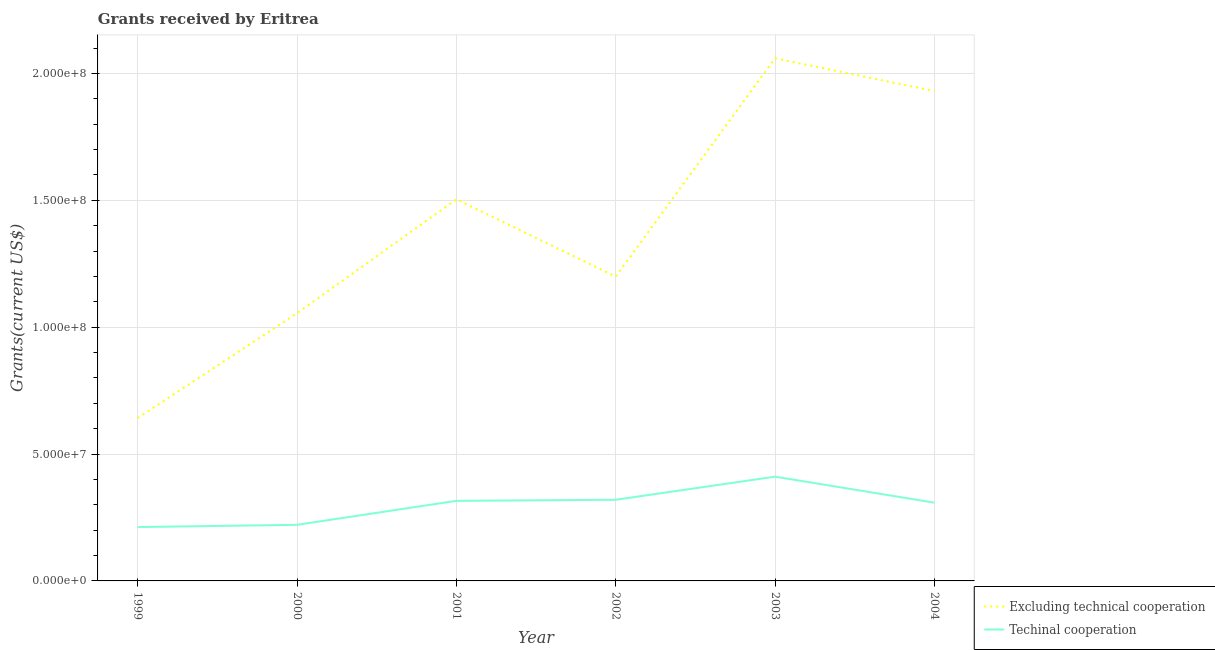Does the line corresponding to amount of grants received(including technical cooperation) intersect with the line corresponding to amount of grants received(excluding technical cooperation)?
Your answer should be compact. No. Is the number of lines equal to the number of legend labels?
Your answer should be compact. Yes. What is the amount of grants received(excluding technical cooperation) in 1999?
Give a very brief answer. 6.42e+07. Across all years, what is the maximum amount of grants received(excluding technical cooperation)?
Offer a very short reply. 2.06e+08. Across all years, what is the minimum amount of grants received(excluding technical cooperation)?
Your answer should be very brief. 6.42e+07. What is the total amount of grants received(including technical cooperation) in the graph?
Give a very brief answer. 1.79e+08. What is the difference between the amount of grants received(excluding technical cooperation) in 1999 and that in 2000?
Offer a terse response. -4.13e+07. What is the difference between the amount of grants received(including technical cooperation) in 2004 and the amount of grants received(excluding technical cooperation) in 2002?
Your answer should be compact. -8.91e+07. What is the average amount of grants received(excluding technical cooperation) per year?
Offer a very short reply. 1.40e+08. In the year 2003, what is the difference between the amount of grants received(including technical cooperation) and amount of grants received(excluding technical cooperation)?
Give a very brief answer. -1.65e+08. What is the ratio of the amount of grants received(including technical cooperation) in 2001 to that in 2002?
Provide a succinct answer. 0.99. Is the amount of grants received(excluding technical cooperation) in 2000 less than that in 2003?
Provide a short and direct response. Yes. What is the difference between the highest and the second highest amount of grants received(including technical cooperation)?
Keep it short and to the point. 9.11e+06. What is the difference between the highest and the lowest amount of grants received(excluding technical cooperation)?
Your response must be concise. 1.42e+08. In how many years, is the amount of grants received(excluding technical cooperation) greater than the average amount of grants received(excluding technical cooperation) taken over all years?
Offer a very short reply. 3. Does the amount of grants received(excluding technical cooperation) monotonically increase over the years?
Keep it short and to the point. No. Is the amount of grants received(including technical cooperation) strictly greater than the amount of grants received(excluding technical cooperation) over the years?
Offer a very short reply. No. Is the amount of grants received(excluding technical cooperation) strictly less than the amount of grants received(including technical cooperation) over the years?
Offer a terse response. No. How many lines are there?
Provide a short and direct response. 2. Are the values on the major ticks of Y-axis written in scientific E-notation?
Offer a very short reply. Yes. Does the graph contain grids?
Your response must be concise. Yes. How are the legend labels stacked?
Offer a very short reply. Vertical. What is the title of the graph?
Make the answer very short. Grants received by Eritrea. Does "Registered firms" appear as one of the legend labels in the graph?
Provide a succinct answer. No. What is the label or title of the X-axis?
Keep it short and to the point. Year. What is the label or title of the Y-axis?
Provide a succinct answer. Grants(current US$). What is the Grants(current US$) in Excluding technical cooperation in 1999?
Your answer should be very brief. 6.42e+07. What is the Grants(current US$) of Techinal cooperation in 1999?
Your response must be concise. 2.12e+07. What is the Grants(current US$) in Excluding technical cooperation in 2000?
Provide a succinct answer. 1.06e+08. What is the Grants(current US$) in Techinal cooperation in 2000?
Your answer should be very brief. 2.21e+07. What is the Grants(current US$) of Excluding technical cooperation in 2001?
Make the answer very short. 1.50e+08. What is the Grants(current US$) of Techinal cooperation in 2001?
Offer a terse response. 3.16e+07. What is the Grants(current US$) of Excluding technical cooperation in 2002?
Provide a succinct answer. 1.20e+08. What is the Grants(current US$) of Techinal cooperation in 2002?
Ensure brevity in your answer.  3.20e+07. What is the Grants(current US$) of Excluding technical cooperation in 2003?
Give a very brief answer. 2.06e+08. What is the Grants(current US$) of Techinal cooperation in 2003?
Offer a very short reply. 4.11e+07. What is the Grants(current US$) in Excluding technical cooperation in 2004?
Provide a succinct answer. 1.93e+08. What is the Grants(current US$) in Techinal cooperation in 2004?
Offer a very short reply. 3.08e+07. Across all years, what is the maximum Grants(current US$) in Excluding technical cooperation?
Provide a succinct answer. 2.06e+08. Across all years, what is the maximum Grants(current US$) in Techinal cooperation?
Make the answer very short. 4.11e+07. Across all years, what is the minimum Grants(current US$) of Excluding technical cooperation?
Give a very brief answer. 6.42e+07. Across all years, what is the minimum Grants(current US$) in Techinal cooperation?
Offer a terse response. 2.12e+07. What is the total Grants(current US$) in Excluding technical cooperation in the graph?
Provide a succinct answer. 8.39e+08. What is the total Grants(current US$) of Techinal cooperation in the graph?
Make the answer very short. 1.79e+08. What is the difference between the Grants(current US$) in Excluding technical cooperation in 1999 and that in 2000?
Your answer should be very brief. -4.13e+07. What is the difference between the Grants(current US$) in Techinal cooperation in 1999 and that in 2000?
Provide a short and direct response. -8.90e+05. What is the difference between the Grants(current US$) of Excluding technical cooperation in 1999 and that in 2001?
Offer a very short reply. -8.62e+07. What is the difference between the Grants(current US$) in Techinal cooperation in 1999 and that in 2001?
Provide a succinct answer. -1.03e+07. What is the difference between the Grants(current US$) in Excluding technical cooperation in 1999 and that in 2002?
Your answer should be compact. -5.58e+07. What is the difference between the Grants(current US$) of Techinal cooperation in 1999 and that in 2002?
Make the answer very short. -1.08e+07. What is the difference between the Grants(current US$) of Excluding technical cooperation in 1999 and that in 2003?
Provide a short and direct response. -1.42e+08. What is the difference between the Grants(current US$) in Techinal cooperation in 1999 and that in 2003?
Provide a short and direct response. -1.99e+07. What is the difference between the Grants(current US$) in Excluding technical cooperation in 1999 and that in 2004?
Ensure brevity in your answer.  -1.29e+08. What is the difference between the Grants(current US$) of Techinal cooperation in 1999 and that in 2004?
Your answer should be compact. -9.62e+06. What is the difference between the Grants(current US$) in Excluding technical cooperation in 2000 and that in 2001?
Keep it short and to the point. -4.49e+07. What is the difference between the Grants(current US$) in Techinal cooperation in 2000 and that in 2001?
Your response must be concise. -9.45e+06. What is the difference between the Grants(current US$) in Excluding technical cooperation in 2000 and that in 2002?
Your response must be concise. -1.44e+07. What is the difference between the Grants(current US$) in Techinal cooperation in 2000 and that in 2002?
Ensure brevity in your answer.  -9.87e+06. What is the difference between the Grants(current US$) in Excluding technical cooperation in 2000 and that in 2003?
Keep it short and to the point. -1.00e+08. What is the difference between the Grants(current US$) in Techinal cooperation in 2000 and that in 2003?
Provide a short and direct response. -1.90e+07. What is the difference between the Grants(current US$) in Excluding technical cooperation in 2000 and that in 2004?
Give a very brief answer. -8.75e+07. What is the difference between the Grants(current US$) in Techinal cooperation in 2000 and that in 2004?
Ensure brevity in your answer.  -8.73e+06. What is the difference between the Grants(current US$) of Excluding technical cooperation in 2001 and that in 2002?
Give a very brief answer. 3.05e+07. What is the difference between the Grants(current US$) of Techinal cooperation in 2001 and that in 2002?
Keep it short and to the point. -4.20e+05. What is the difference between the Grants(current US$) of Excluding technical cooperation in 2001 and that in 2003?
Your response must be concise. -5.56e+07. What is the difference between the Grants(current US$) in Techinal cooperation in 2001 and that in 2003?
Give a very brief answer. -9.53e+06. What is the difference between the Grants(current US$) in Excluding technical cooperation in 2001 and that in 2004?
Keep it short and to the point. -4.26e+07. What is the difference between the Grants(current US$) of Techinal cooperation in 2001 and that in 2004?
Offer a terse response. 7.20e+05. What is the difference between the Grants(current US$) of Excluding technical cooperation in 2002 and that in 2003?
Provide a short and direct response. -8.60e+07. What is the difference between the Grants(current US$) in Techinal cooperation in 2002 and that in 2003?
Make the answer very short. -9.11e+06. What is the difference between the Grants(current US$) of Excluding technical cooperation in 2002 and that in 2004?
Give a very brief answer. -7.31e+07. What is the difference between the Grants(current US$) of Techinal cooperation in 2002 and that in 2004?
Your response must be concise. 1.14e+06. What is the difference between the Grants(current US$) of Excluding technical cooperation in 2003 and that in 2004?
Make the answer very short. 1.29e+07. What is the difference between the Grants(current US$) of Techinal cooperation in 2003 and that in 2004?
Provide a short and direct response. 1.02e+07. What is the difference between the Grants(current US$) of Excluding technical cooperation in 1999 and the Grants(current US$) of Techinal cooperation in 2000?
Your answer should be very brief. 4.21e+07. What is the difference between the Grants(current US$) in Excluding technical cooperation in 1999 and the Grants(current US$) in Techinal cooperation in 2001?
Ensure brevity in your answer.  3.26e+07. What is the difference between the Grants(current US$) in Excluding technical cooperation in 1999 and the Grants(current US$) in Techinal cooperation in 2002?
Your answer should be very brief. 3.22e+07. What is the difference between the Grants(current US$) of Excluding technical cooperation in 1999 and the Grants(current US$) of Techinal cooperation in 2003?
Give a very brief answer. 2.31e+07. What is the difference between the Grants(current US$) in Excluding technical cooperation in 1999 and the Grants(current US$) in Techinal cooperation in 2004?
Ensure brevity in your answer.  3.33e+07. What is the difference between the Grants(current US$) of Excluding technical cooperation in 2000 and the Grants(current US$) of Techinal cooperation in 2001?
Give a very brief answer. 7.40e+07. What is the difference between the Grants(current US$) in Excluding technical cooperation in 2000 and the Grants(current US$) in Techinal cooperation in 2002?
Your answer should be very brief. 7.35e+07. What is the difference between the Grants(current US$) of Excluding technical cooperation in 2000 and the Grants(current US$) of Techinal cooperation in 2003?
Your response must be concise. 6.44e+07. What is the difference between the Grants(current US$) of Excluding technical cooperation in 2000 and the Grants(current US$) of Techinal cooperation in 2004?
Offer a terse response. 7.47e+07. What is the difference between the Grants(current US$) in Excluding technical cooperation in 2001 and the Grants(current US$) in Techinal cooperation in 2002?
Offer a terse response. 1.18e+08. What is the difference between the Grants(current US$) of Excluding technical cooperation in 2001 and the Grants(current US$) of Techinal cooperation in 2003?
Keep it short and to the point. 1.09e+08. What is the difference between the Grants(current US$) of Excluding technical cooperation in 2001 and the Grants(current US$) of Techinal cooperation in 2004?
Offer a terse response. 1.20e+08. What is the difference between the Grants(current US$) of Excluding technical cooperation in 2002 and the Grants(current US$) of Techinal cooperation in 2003?
Keep it short and to the point. 7.88e+07. What is the difference between the Grants(current US$) of Excluding technical cooperation in 2002 and the Grants(current US$) of Techinal cooperation in 2004?
Your answer should be very brief. 8.91e+07. What is the difference between the Grants(current US$) of Excluding technical cooperation in 2003 and the Grants(current US$) of Techinal cooperation in 2004?
Provide a short and direct response. 1.75e+08. What is the average Grants(current US$) in Excluding technical cooperation per year?
Provide a succinct answer. 1.40e+08. What is the average Grants(current US$) of Techinal cooperation per year?
Ensure brevity in your answer.  2.98e+07. In the year 1999, what is the difference between the Grants(current US$) of Excluding technical cooperation and Grants(current US$) of Techinal cooperation?
Ensure brevity in your answer.  4.30e+07. In the year 2000, what is the difference between the Grants(current US$) in Excluding technical cooperation and Grants(current US$) in Techinal cooperation?
Provide a short and direct response. 8.34e+07. In the year 2001, what is the difference between the Grants(current US$) in Excluding technical cooperation and Grants(current US$) in Techinal cooperation?
Ensure brevity in your answer.  1.19e+08. In the year 2002, what is the difference between the Grants(current US$) in Excluding technical cooperation and Grants(current US$) in Techinal cooperation?
Offer a very short reply. 8.80e+07. In the year 2003, what is the difference between the Grants(current US$) in Excluding technical cooperation and Grants(current US$) in Techinal cooperation?
Your answer should be very brief. 1.65e+08. In the year 2004, what is the difference between the Grants(current US$) in Excluding technical cooperation and Grants(current US$) in Techinal cooperation?
Give a very brief answer. 1.62e+08. What is the ratio of the Grants(current US$) of Excluding technical cooperation in 1999 to that in 2000?
Provide a succinct answer. 0.61. What is the ratio of the Grants(current US$) in Techinal cooperation in 1999 to that in 2000?
Ensure brevity in your answer.  0.96. What is the ratio of the Grants(current US$) in Excluding technical cooperation in 1999 to that in 2001?
Offer a terse response. 0.43. What is the ratio of the Grants(current US$) in Techinal cooperation in 1999 to that in 2001?
Your response must be concise. 0.67. What is the ratio of the Grants(current US$) in Excluding technical cooperation in 1999 to that in 2002?
Give a very brief answer. 0.54. What is the ratio of the Grants(current US$) of Techinal cooperation in 1999 to that in 2002?
Give a very brief answer. 0.66. What is the ratio of the Grants(current US$) of Excluding technical cooperation in 1999 to that in 2003?
Make the answer very short. 0.31. What is the ratio of the Grants(current US$) of Techinal cooperation in 1999 to that in 2003?
Make the answer very short. 0.52. What is the ratio of the Grants(current US$) of Excluding technical cooperation in 1999 to that in 2004?
Your answer should be very brief. 0.33. What is the ratio of the Grants(current US$) of Techinal cooperation in 1999 to that in 2004?
Provide a short and direct response. 0.69. What is the ratio of the Grants(current US$) of Excluding technical cooperation in 2000 to that in 2001?
Your answer should be compact. 0.7. What is the ratio of the Grants(current US$) of Techinal cooperation in 2000 to that in 2001?
Keep it short and to the point. 0.7. What is the ratio of the Grants(current US$) in Excluding technical cooperation in 2000 to that in 2002?
Offer a very short reply. 0.88. What is the ratio of the Grants(current US$) of Techinal cooperation in 2000 to that in 2002?
Your answer should be very brief. 0.69. What is the ratio of the Grants(current US$) in Excluding technical cooperation in 2000 to that in 2003?
Offer a very short reply. 0.51. What is the ratio of the Grants(current US$) in Techinal cooperation in 2000 to that in 2003?
Provide a short and direct response. 0.54. What is the ratio of the Grants(current US$) in Excluding technical cooperation in 2000 to that in 2004?
Your response must be concise. 0.55. What is the ratio of the Grants(current US$) in Techinal cooperation in 2000 to that in 2004?
Provide a short and direct response. 0.72. What is the ratio of the Grants(current US$) of Excluding technical cooperation in 2001 to that in 2002?
Ensure brevity in your answer.  1.25. What is the ratio of the Grants(current US$) in Techinal cooperation in 2001 to that in 2002?
Your response must be concise. 0.99. What is the ratio of the Grants(current US$) in Excluding technical cooperation in 2001 to that in 2003?
Ensure brevity in your answer.  0.73. What is the ratio of the Grants(current US$) in Techinal cooperation in 2001 to that in 2003?
Ensure brevity in your answer.  0.77. What is the ratio of the Grants(current US$) of Excluding technical cooperation in 2001 to that in 2004?
Keep it short and to the point. 0.78. What is the ratio of the Grants(current US$) of Techinal cooperation in 2001 to that in 2004?
Your answer should be compact. 1.02. What is the ratio of the Grants(current US$) in Excluding technical cooperation in 2002 to that in 2003?
Provide a succinct answer. 0.58. What is the ratio of the Grants(current US$) in Techinal cooperation in 2002 to that in 2003?
Your answer should be compact. 0.78. What is the ratio of the Grants(current US$) in Excluding technical cooperation in 2002 to that in 2004?
Make the answer very short. 0.62. What is the ratio of the Grants(current US$) in Excluding technical cooperation in 2003 to that in 2004?
Your answer should be compact. 1.07. What is the ratio of the Grants(current US$) of Techinal cooperation in 2003 to that in 2004?
Give a very brief answer. 1.33. What is the difference between the highest and the second highest Grants(current US$) in Excluding technical cooperation?
Ensure brevity in your answer.  1.29e+07. What is the difference between the highest and the second highest Grants(current US$) of Techinal cooperation?
Provide a short and direct response. 9.11e+06. What is the difference between the highest and the lowest Grants(current US$) in Excluding technical cooperation?
Ensure brevity in your answer.  1.42e+08. What is the difference between the highest and the lowest Grants(current US$) in Techinal cooperation?
Provide a short and direct response. 1.99e+07. 